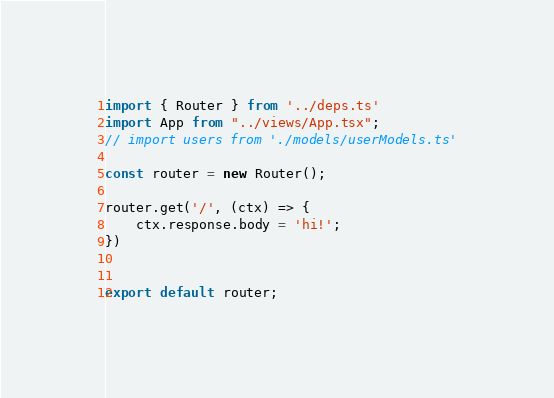Convert code to text. <code><loc_0><loc_0><loc_500><loc_500><_TypeScript_>import { Router } from '../deps.ts'
import App from "../views/App.tsx";
// import users from './models/userModels.ts'

const router = new Router();

router.get('/', (ctx) => {
    ctx.response.body = 'hi!';
})


export default router;


</code> 